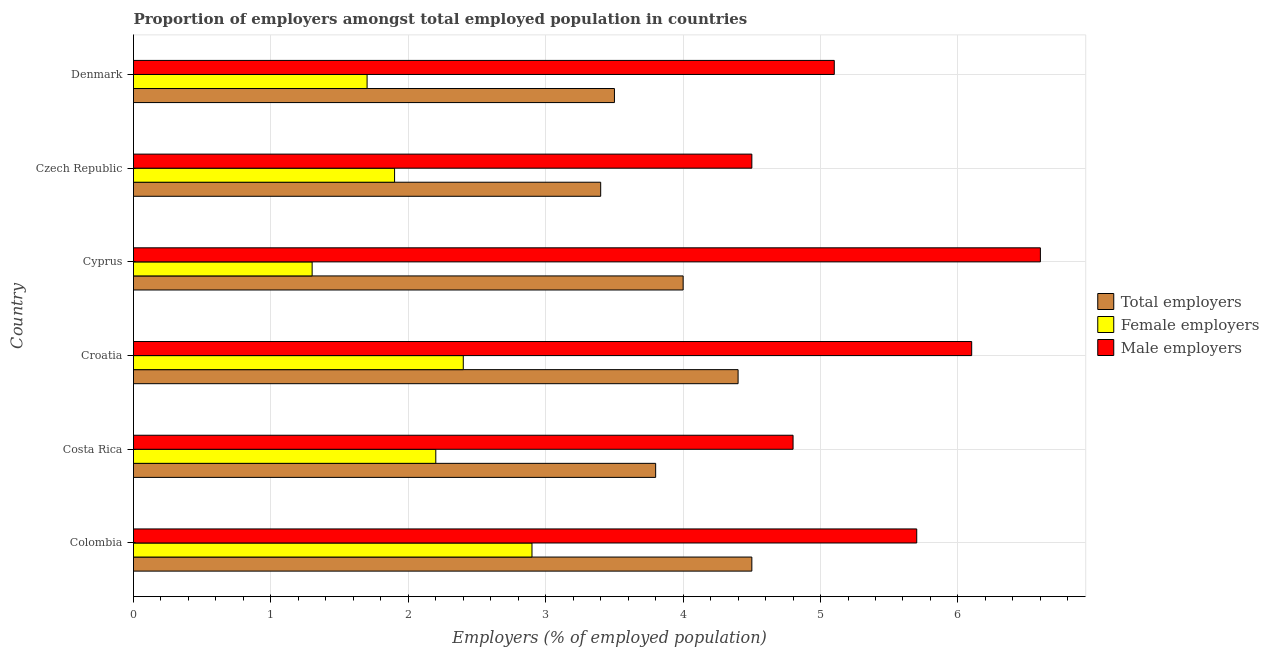Are the number of bars per tick equal to the number of legend labels?
Make the answer very short. Yes. What is the label of the 1st group of bars from the top?
Your answer should be compact. Denmark. What is the percentage of female employers in Denmark?
Offer a terse response. 1.7. In which country was the percentage of total employers maximum?
Your response must be concise. Colombia. In which country was the percentage of female employers minimum?
Keep it short and to the point. Cyprus. What is the total percentage of total employers in the graph?
Make the answer very short. 23.6. What is the difference between the percentage of total employers in Colombia and that in Costa Rica?
Make the answer very short. 0.7. What is the difference between the percentage of female employers in Costa Rica and the percentage of male employers in Colombia?
Your answer should be compact. -3.5. What is the average percentage of total employers per country?
Give a very brief answer. 3.93. What is the difference between the percentage of female employers and percentage of male employers in Czech Republic?
Keep it short and to the point. -2.6. In how many countries, is the percentage of total employers greater than 0.8 %?
Your answer should be very brief. 6. What is the ratio of the percentage of female employers in Croatia to that in Cyprus?
Your answer should be compact. 1.85. What is the difference between the highest and the second highest percentage of male employers?
Provide a short and direct response. 0.5. What is the difference between the highest and the lowest percentage of female employers?
Provide a short and direct response. 1.6. In how many countries, is the percentage of male employers greater than the average percentage of male employers taken over all countries?
Offer a very short reply. 3. What does the 2nd bar from the top in Colombia represents?
Your answer should be very brief. Female employers. What does the 3rd bar from the bottom in Colombia represents?
Offer a very short reply. Male employers. How many bars are there?
Your answer should be compact. 18. Are all the bars in the graph horizontal?
Give a very brief answer. Yes. How many countries are there in the graph?
Provide a succinct answer. 6. What is the difference between two consecutive major ticks on the X-axis?
Your answer should be very brief. 1. Does the graph contain grids?
Ensure brevity in your answer.  Yes. Where does the legend appear in the graph?
Ensure brevity in your answer.  Center right. How many legend labels are there?
Keep it short and to the point. 3. How are the legend labels stacked?
Offer a very short reply. Vertical. What is the title of the graph?
Your answer should be very brief. Proportion of employers amongst total employed population in countries. Does "Capital account" appear as one of the legend labels in the graph?
Provide a succinct answer. No. What is the label or title of the X-axis?
Your answer should be compact. Employers (% of employed population). What is the Employers (% of employed population) of Female employers in Colombia?
Ensure brevity in your answer.  2.9. What is the Employers (% of employed population) of Male employers in Colombia?
Provide a succinct answer. 5.7. What is the Employers (% of employed population) of Total employers in Costa Rica?
Offer a very short reply. 3.8. What is the Employers (% of employed population) of Female employers in Costa Rica?
Make the answer very short. 2.2. What is the Employers (% of employed population) of Male employers in Costa Rica?
Your answer should be compact. 4.8. What is the Employers (% of employed population) in Total employers in Croatia?
Give a very brief answer. 4.4. What is the Employers (% of employed population) of Female employers in Croatia?
Offer a very short reply. 2.4. What is the Employers (% of employed population) in Male employers in Croatia?
Make the answer very short. 6.1. What is the Employers (% of employed population) of Female employers in Cyprus?
Offer a very short reply. 1.3. What is the Employers (% of employed population) in Male employers in Cyprus?
Provide a short and direct response. 6.6. What is the Employers (% of employed population) of Total employers in Czech Republic?
Give a very brief answer. 3.4. What is the Employers (% of employed population) of Female employers in Czech Republic?
Your response must be concise. 1.9. What is the Employers (% of employed population) in Male employers in Czech Republic?
Keep it short and to the point. 4.5. What is the Employers (% of employed population) in Total employers in Denmark?
Provide a succinct answer. 3.5. What is the Employers (% of employed population) in Female employers in Denmark?
Provide a short and direct response. 1.7. What is the Employers (% of employed population) in Male employers in Denmark?
Your response must be concise. 5.1. Across all countries, what is the maximum Employers (% of employed population) of Total employers?
Keep it short and to the point. 4.5. Across all countries, what is the maximum Employers (% of employed population) in Female employers?
Your response must be concise. 2.9. Across all countries, what is the maximum Employers (% of employed population) in Male employers?
Keep it short and to the point. 6.6. Across all countries, what is the minimum Employers (% of employed population) in Total employers?
Your answer should be very brief. 3.4. Across all countries, what is the minimum Employers (% of employed population) in Female employers?
Provide a succinct answer. 1.3. What is the total Employers (% of employed population) in Total employers in the graph?
Your answer should be compact. 23.6. What is the total Employers (% of employed population) of Female employers in the graph?
Provide a succinct answer. 12.4. What is the total Employers (% of employed population) of Male employers in the graph?
Provide a succinct answer. 32.8. What is the difference between the Employers (% of employed population) in Male employers in Colombia and that in Costa Rica?
Offer a very short reply. 0.9. What is the difference between the Employers (% of employed population) in Total employers in Colombia and that in Croatia?
Offer a very short reply. 0.1. What is the difference between the Employers (% of employed population) of Male employers in Colombia and that in Croatia?
Offer a terse response. -0.4. What is the difference between the Employers (% of employed population) in Total employers in Colombia and that in Cyprus?
Ensure brevity in your answer.  0.5. What is the difference between the Employers (% of employed population) of Female employers in Colombia and that in Cyprus?
Your answer should be compact. 1.6. What is the difference between the Employers (% of employed population) in Total employers in Colombia and that in Czech Republic?
Keep it short and to the point. 1.1. What is the difference between the Employers (% of employed population) of Female employers in Colombia and that in Denmark?
Your answer should be very brief. 1.2. What is the difference between the Employers (% of employed population) in Total employers in Costa Rica and that in Croatia?
Keep it short and to the point. -0.6. What is the difference between the Employers (% of employed population) in Female employers in Costa Rica and that in Croatia?
Give a very brief answer. -0.2. What is the difference between the Employers (% of employed population) in Female employers in Costa Rica and that in Cyprus?
Your response must be concise. 0.9. What is the difference between the Employers (% of employed population) in Female employers in Costa Rica and that in Czech Republic?
Offer a very short reply. 0.3. What is the difference between the Employers (% of employed population) in Female employers in Croatia and that in Czech Republic?
Your response must be concise. 0.5. What is the difference between the Employers (% of employed population) in Male employers in Croatia and that in Denmark?
Ensure brevity in your answer.  1. What is the difference between the Employers (% of employed population) of Total employers in Cyprus and that in Czech Republic?
Provide a short and direct response. 0.6. What is the difference between the Employers (% of employed population) in Male employers in Cyprus and that in Czech Republic?
Your answer should be compact. 2.1. What is the difference between the Employers (% of employed population) in Total employers in Cyprus and that in Denmark?
Make the answer very short. 0.5. What is the difference between the Employers (% of employed population) of Female employers in Cyprus and that in Denmark?
Your response must be concise. -0.4. What is the difference between the Employers (% of employed population) in Total employers in Czech Republic and that in Denmark?
Provide a short and direct response. -0.1. What is the difference between the Employers (% of employed population) of Total employers in Colombia and the Employers (% of employed population) of Female employers in Costa Rica?
Keep it short and to the point. 2.3. What is the difference between the Employers (% of employed population) in Total employers in Colombia and the Employers (% of employed population) in Male employers in Costa Rica?
Make the answer very short. -0.3. What is the difference between the Employers (% of employed population) in Female employers in Colombia and the Employers (% of employed population) in Male employers in Croatia?
Give a very brief answer. -3.2. What is the difference between the Employers (% of employed population) of Total employers in Colombia and the Employers (% of employed population) of Female employers in Cyprus?
Offer a terse response. 3.2. What is the difference between the Employers (% of employed population) in Total employers in Colombia and the Employers (% of employed population) in Male employers in Cyprus?
Offer a very short reply. -2.1. What is the difference between the Employers (% of employed population) of Female employers in Colombia and the Employers (% of employed population) of Male employers in Cyprus?
Your answer should be very brief. -3.7. What is the difference between the Employers (% of employed population) of Total employers in Colombia and the Employers (% of employed population) of Female employers in Czech Republic?
Give a very brief answer. 2.6. What is the difference between the Employers (% of employed population) in Female employers in Colombia and the Employers (% of employed population) in Male employers in Czech Republic?
Make the answer very short. -1.6. What is the difference between the Employers (% of employed population) of Total employers in Costa Rica and the Employers (% of employed population) of Male employers in Croatia?
Your answer should be very brief. -2.3. What is the difference between the Employers (% of employed population) in Female employers in Costa Rica and the Employers (% of employed population) in Male employers in Croatia?
Offer a very short reply. -3.9. What is the difference between the Employers (% of employed population) of Female employers in Costa Rica and the Employers (% of employed population) of Male employers in Cyprus?
Your answer should be compact. -4.4. What is the difference between the Employers (% of employed population) in Total employers in Costa Rica and the Employers (% of employed population) in Female employers in Denmark?
Keep it short and to the point. 2.1. What is the difference between the Employers (% of employed population) of Total employers in Costa Rica and the Employers (% of employed population) of Male employers in Denmark?
Ensure brevity in your answer.  -1.3. What is the difference between the Employers (% of employed population) in Female employers in Costa Rica and the Employers (% of employed population) in Male employers in Denmark?
Your response must be concise. -2.9. What is the difference between the Employers (% of employed population) of Total employers in Croatia and the Employers (% of employed population) of Female employers in Cyprus?
Make the answer very short. 3.1. What is the difference between the Employers (% of employed population) of Female employers in Croatia and the Employers (% of employed population) of Male employers in Cyprus?
Your answer should be very brief. -4.2. What is the difference between the Employers (% of employed population) of Total employers in Croatia and the Employers (% of employed population) of Male employers in Denmark?
Your response must be concise. -0.7. What is the difference between the Employers (% of employed population) of Total employers in Cyprus and the Employers (% of employed population) of Female employers in Czech Republic?
Give a very brief answer. 2.1. What is the difference between the Employers (% of employed population) in Total employers in Cyprus and the Employers (% of employed population) in Male employers in Czech Republic?
Offer a terse response. -0.5. What is the difference between the Employers (% of employed population) of Female employers in Cyprus and the Employers (% of employed population) of Male employers in Czech Republic?
Offer a terse response. -3.2. What is the difference between the Employers (% of employed population) of Total employers in Cyprus and the Employers (% of employed population) of Male employers in Denmark?
Your answer should be very brief. -1.1. What is the difference between the Employers (% of employed population) of Female employers in Czech Republic and the Employers (% of employed population) of Male employers in Denmark?
Offer a very short reply. -3.2. What is the average Employers (% of employed population) in Total employers per country?
Keep it short and to the point. 3.93. What is the average Employers (% of employed population) in Female employers per country?
Keep it short and to the point. 2.07. What is the average Employers (% of employed population) of Male employers per country?
Provide a succinct answer. 5.47. What is the difference between the Employers (% of employed population) of Total employers and Employers (% of employed population) of Male employers in Colombia?
Your answer should be very brief. -1.2. What is the difference between the Employers (% of employed population) in Female employers and Employers (% of employed population) in Male employers in Colombia?
Provide a short and direct response. -2.8. What is the difference between the Employers (% of employed population) in Total employers and Employers (% of employed population) in Female employers in Costa Rica?
Your answer should be very brief. 1.6. What is the difference between the Employers (% of employed population) in Female employers and Employers (% of employed population) in Male employers in Costa Rica?
Ensure brevity in your answer.  -2.6. What is the difference between the Employers (% of employed population) of Total employers and Employers (% of employed population) of Female employers in Croatia?
Offer a very short reply. 2. What is the difference between the Employers (% of employed population) in Female employers and Employers (% of employed population) in Male employers in Cyprus?
Provide a short and direct response. -5.3. What is the difference between the Employers (% of employed population) of Total employers and Employers (% of employed population) of Female employers in Czech Republic?
Provide a short and direct response. 1.5. What is the difference between the Employers (% of employed population) of Female employers and Employers (% of employed population) of Male employers in Czech Republic?
Offer a terse response. -2.6. What is the difference between the Employers (% of employed population) of Total employers and Employers (% of employed population) of Male employers in Denmark?
Offer a very short reply. -1.6. What is the difference between the Employers (% of employed population) in Female employers and Employers (% of employed population) in Male employers in Denmark?
Offer a terse response. -3.4. What is the ratio of the Employers (% of employed population) in Total employers in Colombia to that in Costa Rica?
Offer a very short reply. 1.18. What is the ratio of the Employers (% of employed population) in Female employers in Colombia to that in Costa Rica?
Your answer should be compact. 1.32. What is the ratio of the Employers (% of employed population) of Male employers in Colombia to that in Costa Rica?
Your answer should be compact. 1.19. What is the ratio of the Employers (% of employed population) of Total employers in Colombia to that in Croatia?
Make the answer very short. 1.02. What is the ratio of the Employers (% of employed population) in Female employers in Colombia to that in Croatia?
Provide a succinct answer. 1.21. What is the ratio of the Employers (% of employed population) in Male employers in Colombia to that in Croatia?
Your answer should be very brief. 0.93. What is the ratio of the Employers (% of employed population) of Female employers in Colombia to that in Cyprus?
Give a very brief answer. 2.23. What is the ratio of the Employers (% of employed population) in Male employers in Colombia to that in Cyprus?
Your response must be concise. 0.86. What is the ratio of the Employers (% of employed population) in Total employers in Colombia to that in Czech Republic?
Offer a terse response. 1.32. What is the ratio of the Employers (% of employed population) in Female employers in Colombia to that in Czech Republic?
Offer a terse response. 1.53. What is the ratio of the Employers (% of employed population) of Male employers in Colombia to that in Czech Republic?
Your answer should be very brief. 1.27. What is the ratio of the Employers (% of employed population) in Total employers in Colombia to that in Denmark?
Provide a short and direct response. 1.29. What is the ratio of the Employers (% of employed population) in Female employers in Colombia to that in Denmark?
Provide a succinct answer. 1.71. What is the ratio of the Employers (% of employed population) of Male employers in Colombia to that in Denmark?
Your response must be concise. 1.12. What is the ratio of the Employers (% of employed population) of Total employers in Costa Rica to that in Croatia?
Your answer should be compact. 0.86. What is the ratio of the Employers (% of employed population) in Male employers in Costa Rica to that in Croatia?
Offer a very short reply. 0.79. What is the ratio of the Employers (% of employed population) of Female employers in Costa Rica to that in Cyprus?
Your response must be concise. 1.69. What is the ratio of the Employers (% of employed population) of Male employers in Costa Rica to that in Cyprus?
Your response must be concise. 0.73. What is the ratio of the Employers (% of employed population) in Total employers in Costa Rica to that in Czech Republic?
Your response must be concise. 1.12. What is the ratio of the Employers (% of employed population) of Female employers in Costa Rica to that in Czech Republic?
Offer a terse response. 1.16. What is the ratio of the Employers (% of employed population) of Male employers in Costa Rica to that in Czech Republic?
Your response must be concise. 1.07. What is the ratio of the Employers (% of employed population) in Total employers in Costa Rica to that in Denmark?
Ensure brevity in your answer.  1.09. What is the ratio of the Employers (% of employed population) of Female employers in Costa Rica to that in Denmark?
Provide a short and direct response. 1.29. What is the ratio of the Employers (% of employed population) of Total employers in Croatia to that in Cyprus?
Your response must be concise. 1.1. What is the ratio of the Employers (% of employed population) in Female employers in Croatia to that in Cyprus?
Offer a terse response. 1.85. What is the ratio of the Employers (% of employed population) in Male employers in Croatia to that in Cyprus?
Your response must be concise. 0.92. What is the ratio of the Employers (% of employed population) of Total employers in Croatia to that in Czech Republic?
Offer a very short reply. 1.29. What is the ratio of the Employers (% of employed population) of Female employers in Croatia to that in Czech Republic?
Offer a terse response. 1.26. What is the ratio of the Employers (% of employed population) in Male employers in Croatia to that in Czech Republic?
Offer a terse response. 1.36. What is the ratio of the Employers (% of employed population) of Total employers in Croatia to that in Denmark?
Keep it short and to the point. 1.26. What is the ratio of the Employers (% of employed population) of Female employers in Croatia to that in Denmark?
Ensure brevity in your answer.  1.41. What is the ratio of the Employers (% of employed population) in Male employers in Croatia to that in Denmark?
Ensure brevity in your answer.  1.2. What is the ratio of the Employers (% of employed population) in Total employers in Cyprus to that in Czech Republic?
Provide a short and direct response. 1.18. What is the ratio of the Employers (% of employed population) of Female employers in Cyprus to that in Czech Republic?
Ensure brevity in your answer.  0.68. What is the ratio of the Employers (% of employed population) in Male employers in Cyprus to that in Czech Republic?
Make the answer very short. 1.47. What is the ratio of the Employers (% of employed population) of Total employers in Cyprus to that in Denmark?
Offer a very short reply. 1.14. What is the ratio of the Employers (% of employed population) in Female employers in Cyprus to that in Denmark?
Your answer should be compact. 0.76. What is the ratio of the Employers (% of employed population) of Male employers in Cyprus to that in Denmark?
Provide a short and direct response. 1.29. What is the ratio of the Employers (% of employed population) in Total employers in Czech Republic to that in Denmark?
Your answer should be very brief. 0.97. What is the ratio of the Employers (% of employed population) of Female employers in Czech Republic to that in Denmark?
Provide a succinct answer. 1.12. What is the ratio of the Employers (% of employed population) in Male employers in Czech Republic to that in Denmark?
Offer a very short reply. 0.88. What is the difference between the highest and the second highest Employers (% of employed population) in Total employers?
Ensure brevity in your answer.  0.1. What is the difference between the highest and the lowest Employers (% of employed population) of Male employers?
Offer a very short reply. 2.1. 